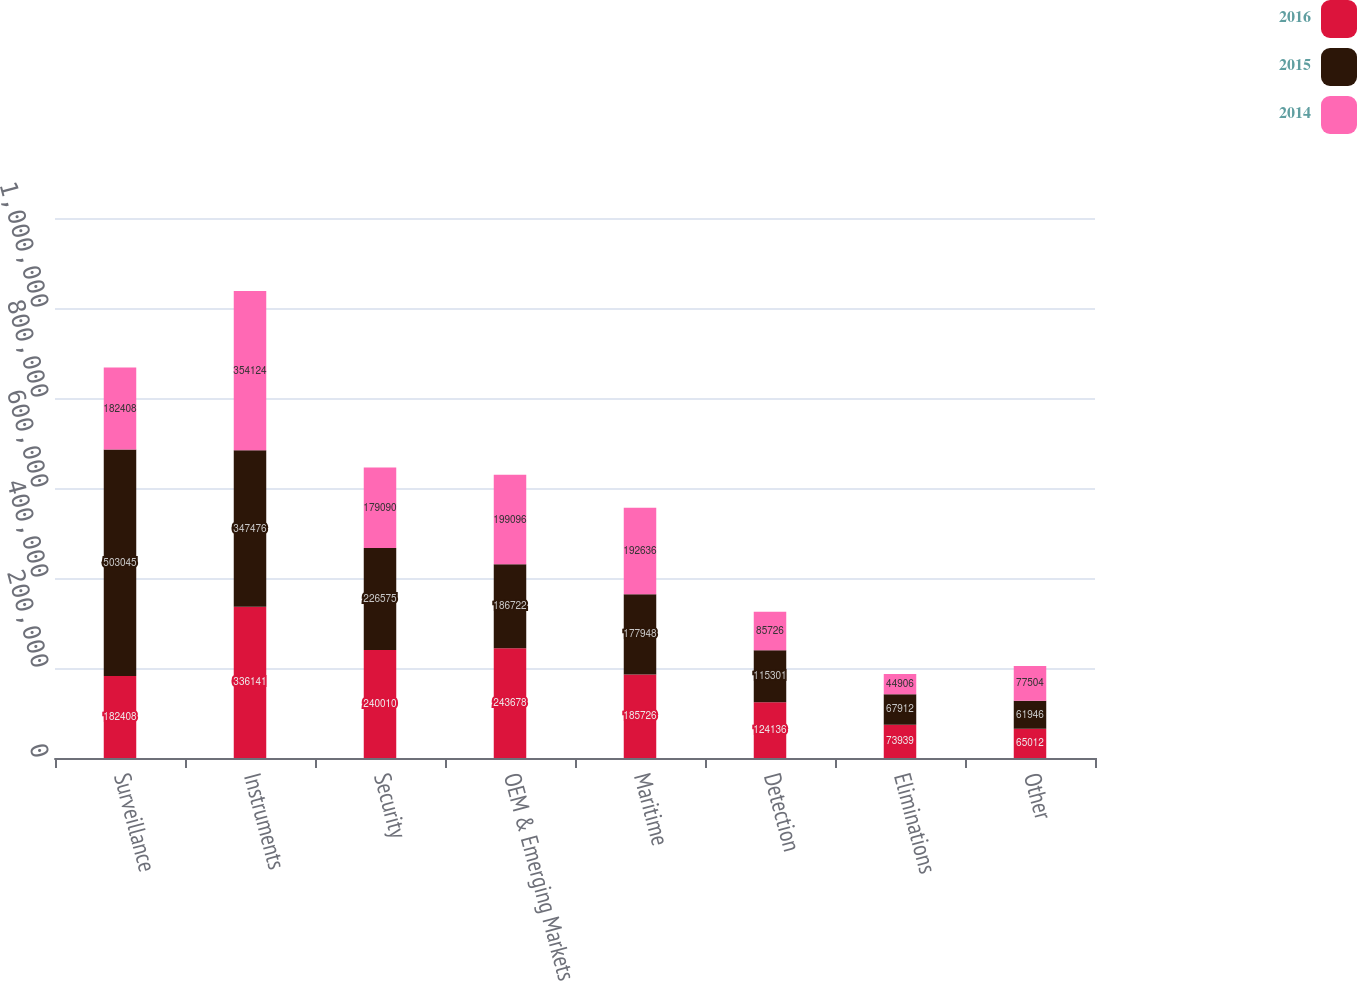<chart> <loc_0><loc_0><loc_500><loc_500><stacked_bar_chart><ecel><fcel>Surveillance<fcel>Instruments<fcel>Security<fcel>OEM & Emerging Markets<fcel>Maritime<fcel>Detection<fcel>Eliminations<fcel>Other<nl><fcel>2016<fcel>182408<fcel>336141<fcel>240010<fcel>243678<fcel>185726<fcel>124136<fcel>73939<fcel>65012<nl><fcel>2015<fcel>503045<fcel>347476<fcel>226575<fcel>186722<fcel>177948<fcel>115301<fcel>67912<fcel>61946<nl><fcel>2014<fcel>182408<fcel>354124<fcel>179090<fcel>199096<fcel>192636<fcel>85726<fcel>44906<fcel>77504<nl></chart> 